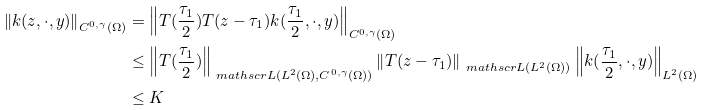Convert formula to latex. <formula><loc_0><loc_0><loc_500><loc_500>\left \| k ( z , \cdot , y ) \right \| _ { C ^ { 0 , \gamma } ( \Omega ) } & = \left \| T ( \frac { \tau _ { 1 } } { 2 } ) T ( z - \tau _ { 1 } ) k ( \frac { \tau _ { 1 } } { 2 } , \cdot , y ) \right \| _ { C ^ { 0 , \gamma } ( \Omega ) } \\ & \leq \left \| T ( \frac { \tau _ { 1 } } { 2 } ) \right \| _ { \ m a t h s c r { L } ( L ^ { 2 } ( \Omega ) , C ^ { 0 , \gamma } ( \Omega ) ) } \left \| T ( z - \tau _ { 1 } ) \right \| _ { \ m a t h s c r { L } ( L ^ { 2 } ( \Omega ) ) } \left \| k ( \frac { \tau _ { 1 } } { 2 } , \cdot , y ) \right \| _ { L ^ { 2 } ( \Omega ) } \\ & \leq K</formula> 